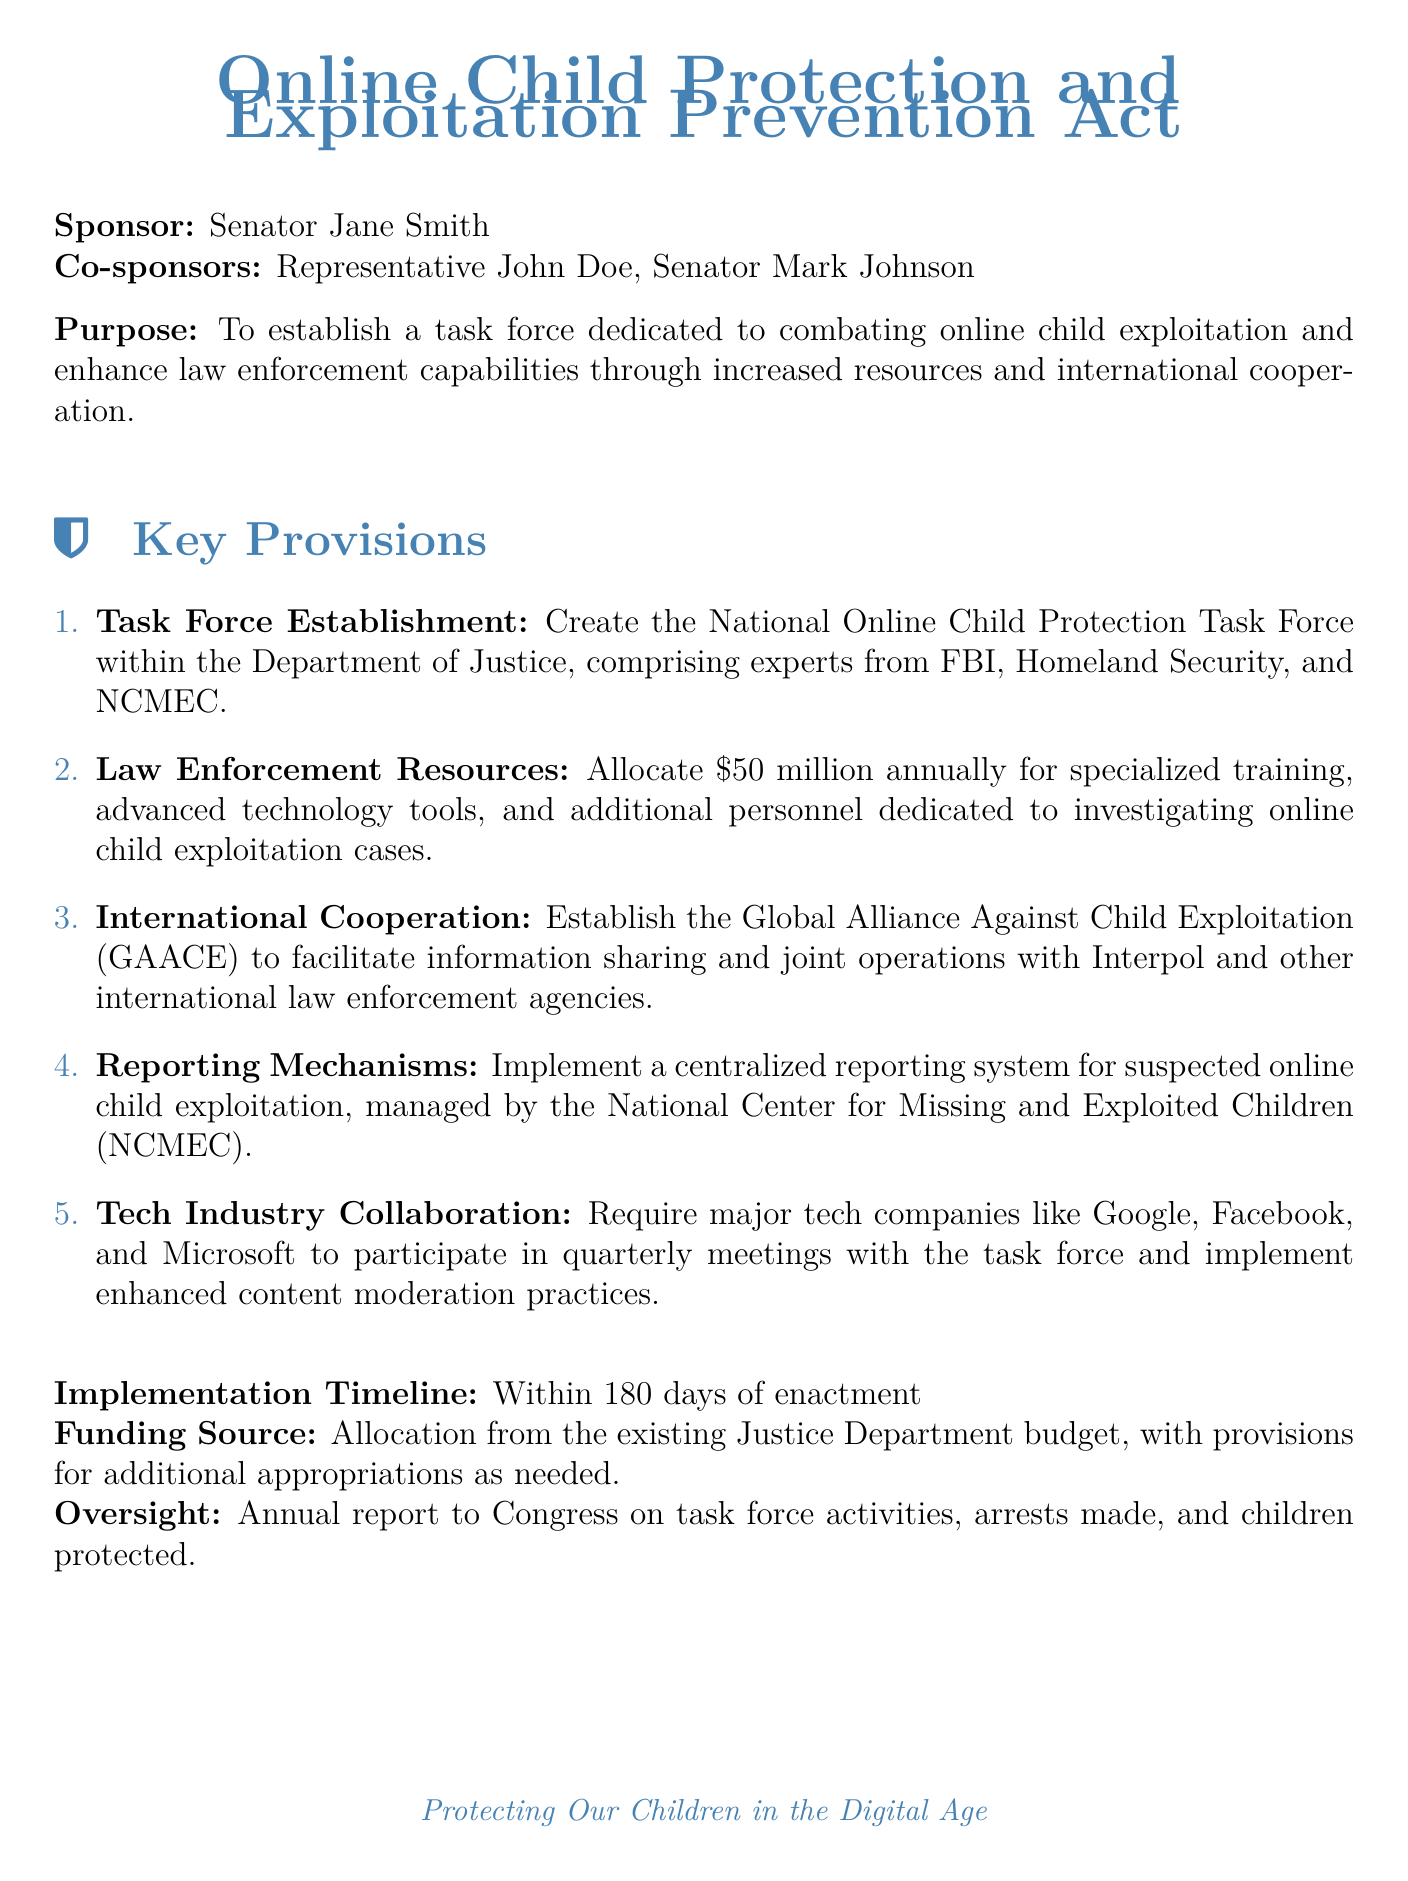What is the bill's title? The title of the bill is stated in the document's header, which is "Online Child Protection and Exploitation Prevention Act".
Answer: Online Child Protection and Exploitation Prevention Act Who is the sponsor of the bill? The document clearly states the sponsor's name in the header section.
Answer: Senator Jane Smith How much funding is allocated annually for law enforcement resources? The document specifies the amount of funding allocated annually for law enforcement resources as part of the key provisions.
Answer: 50 million What is the purpose of establishing the Global Alliance Against Child Exploitation? This provision focuses on international law enforcement collaboration, facilitating information sharing and joint operations.
Answer: Facilitate information sharing and joint operations Which organization will manage the centralized reporting system? The bill specifies the organization responsible for managing the reporting system for suspected online child exploitation cases.
Answer: National Center for Missing and Exploited Children What is the implementation timeline for the task force? The document includes a specific timeframe for when the task force should be implemented.
Answer: Within 180 days of enactment What is required from major tech companies in relation to the task force? The document states a requirement for participation from major tech companies in terms of collaboration with the task force.
Answer: Participate in quarterly meetings with the task force What type of report will be provided to Congress? The document mentions the type of report that the task force will submit annually to Congress.
Answer: Annual report on task force activities How many co-sponsors are listed for the bill? The number of co-sponsors is specified in the introductory section of the document.
Answer: Two 